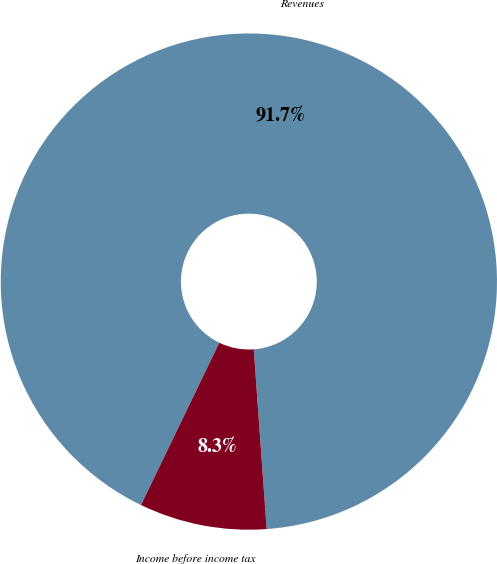Convert chart to OTSL. <chart><loc_0><loc_0><loc_500><loc_500><pie_chart><fcel>Revenues<fcel>Income before income tax<nl><fcel>91.7%<fcel>8.3%<nl></chart> 